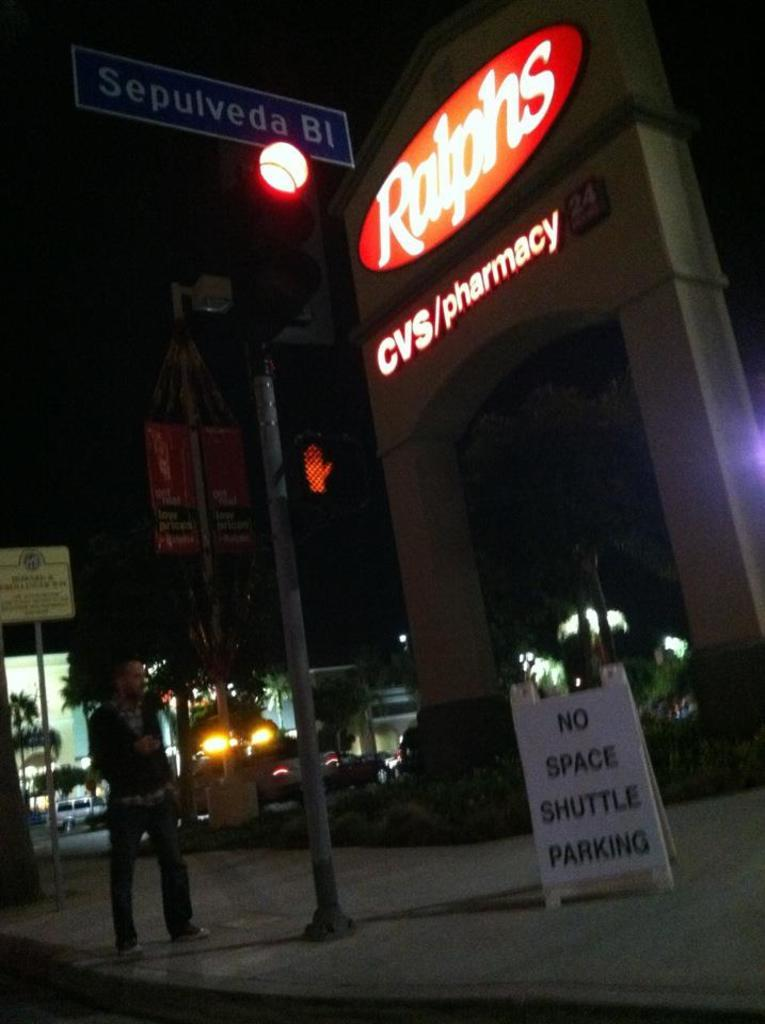What is happening on the road in the image? There is a person on the road in the image. What can be seen near the road in the image? There is a traffic signal in the image. What type of structures are present in the image? There are boards in the image. What type of natural elements are present in the image? There are trees in the image. What type of man-made objects are present in the image? There are vehicles and some objects in the image. How would you describe the lighting in the image? The background of the image is dark. What type of school can be seen in the image? There is no school present in the image. What type of birth is depicted in the image? There is no birth depicted in the image. What type of breakfast is being prepared in the image? There is no breakfast preparation depicted in the image. 